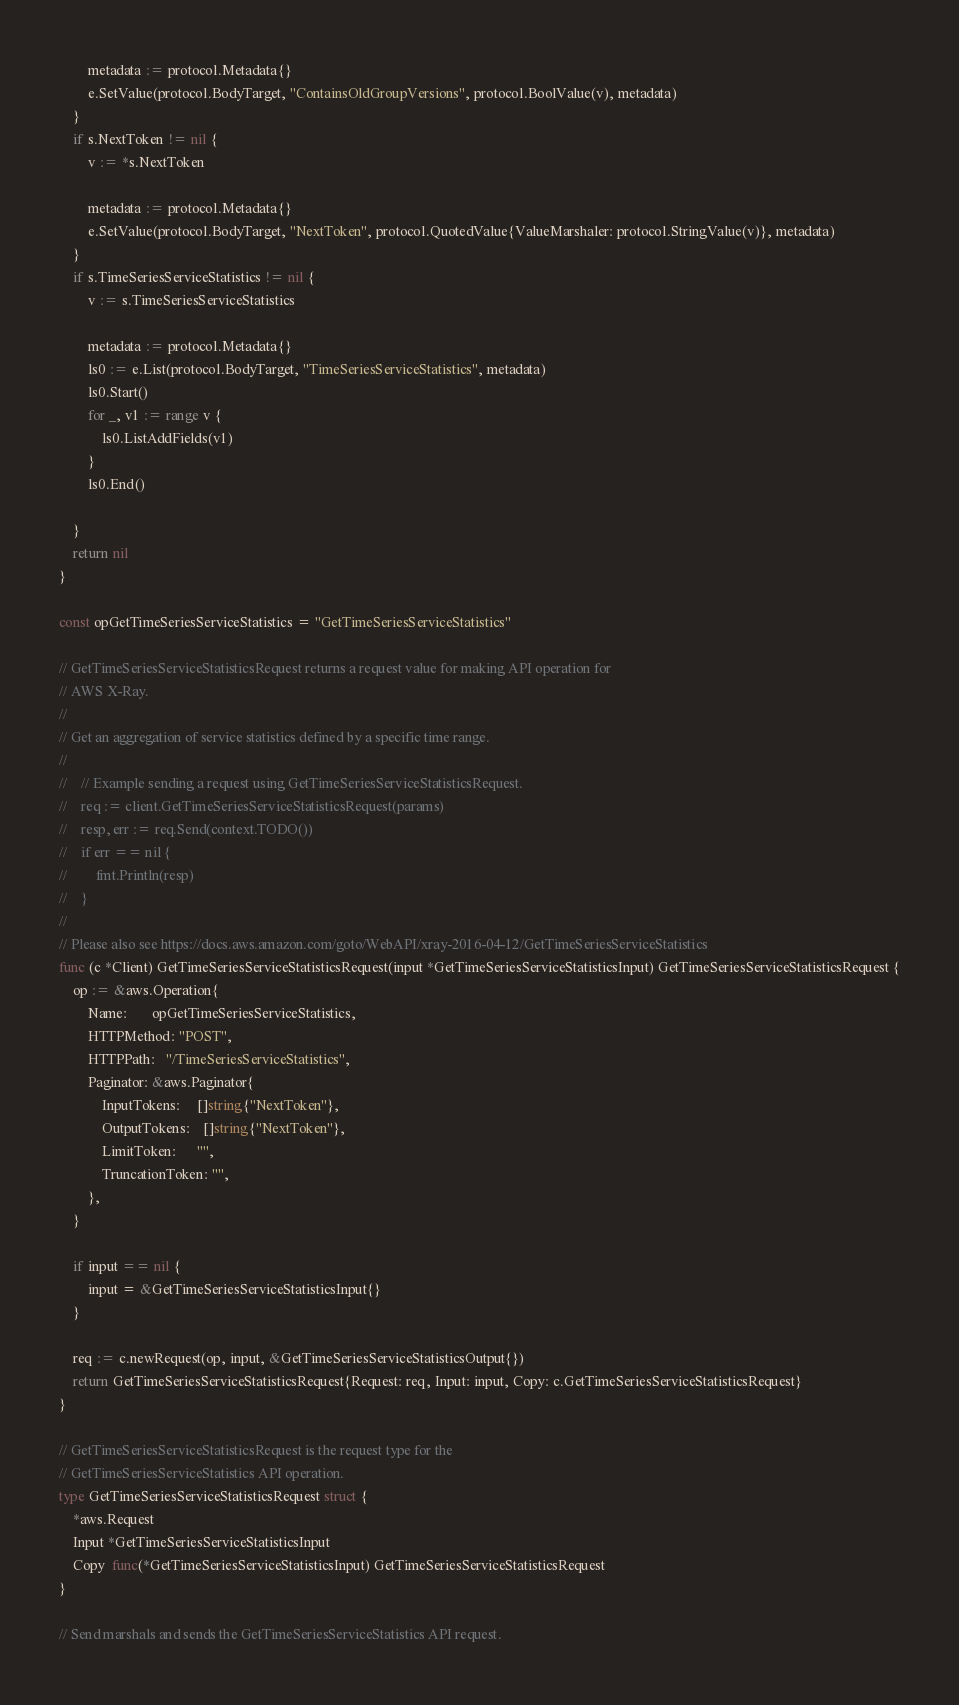Convert code to text. <code><loc_0><loc_0><loc_500><loc_500><_Go_>
		metadata := protocol.Metadata{}
		e.SetValue(protocol.BodyTarget, "ContainsOldGroupVersions", protocol.BoolValue(v), metadata)
	}
	if s.NextToken != nil {
		v := *s.NextToken

		metadata := protocol.Metadata{}
		e.SetValue(protocol.BodyTarget, "NextToken", protocol.QuotedValue{ValueMarshaler: protocol.StringValue(v)}, metadata)
	}
	if s.TimeSeriesServiceStatistics != nil {
		v := s.TimeSeriesServiceStatistics

		metadata := protocol.Metadata{}
		ls0 := e.List(protocol.BodyTarget, "TimeSeriesServiceStatistics", metadata)
		ls0.Start()
		for _, v1 := range v {
			ls0.ListAddFields(v1)
		}
		ls0.End()

	}
	return nil
}

const opGetTimeSeriesServiceStatistics = "GetTimeSeriesServiceStatistics"

// GetTimeSeriesServiceStatisticsRequest returns a request value for making API operation for
// AWS X-Ray.
//
// Get an aggregation of service statistics defined by a specific time range.
//
//    // Example sending a request using GetTimeSeriesServiceStatisticsRequest.
//    req := client.GetTimeSeriesServiceStatisticsRequest(params)
//    resp, err := req.Send(context.TODO())
//    if err == nil {
//        fmt.Println(resp)
//    }
//
// Please also see https://docs.aws.amazon.com/goto/WebAPI/xray-2016-04-12/GetTimeSeriesServiceStatistics
func (c *Client) GetTimeSeriesServiceStatisticsRequest(input *GetTimeSeriesServiceStatisticsInput) GetTimeSeriesServiceStatisticsRequest {
	op := &aws.Operation{
		Name:       opGetTimeSeriesServiceStatistics,
		HTTPMethod: "POST",
		HTTPPath:   "/TimeSeriesServiceStatistics",
		Paginator: &aws.Paginator{
			InputTokens:     []string{"NextToken"},
			OutputTokens:    []string{"NextToken"},
			LimitToken:      "",
			TruncationToken: "",
		},
	}

	if input == nil {
		input = &GetTimeSeriesServiceStatisticsInput{}
	}

	req := c.newRequest(op, input, &GetTimeSeriesServiceStatisticsOutput{})
	return GetTimeSeriesServiceStatisticsRequest{Request: req, Input: input, Copy: c.GetTimeSeriesServiceStatisticsRequest}
}

// GetTimeSeriesServiceStatisticsRequest is the request type for the
// GetTimeSeriesServiceStatistics API operation.
type GetTimeSeriesServiceStatisticsRequest struct {
	*aws.Request
	Input *GetTimeSeriesServiceStatisticsInput
	Copy  func(*GetTimeSeriesServiceStatisticsInput) GetTimeSeriesServiceStatisticsRequest
}

// Send marshals and sends the GetTimeSeriesServiceStatistics API request.</code> 